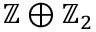Convert formula to latex. <formula><loc_0><loc_0><loc_500><loc_500>\mathbb { Z } \oplus \mathbb { Z } _ { 2 }</formula> 